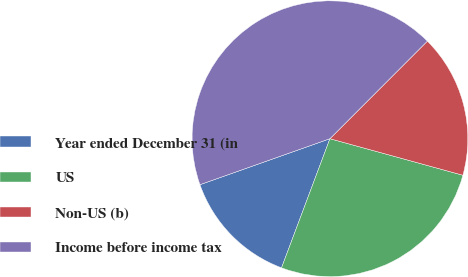Convert chart to OTSL. <chart><loc_0><loc_0><loc_500><loc_500><pie_chart><fcel>Year ended December 31 (in<fcel>US<fcel>Non-US (b)<fcel>Income before income tax<nl><fcel>13.88%<fcel>26.44%<fcel>16.78%<fcel>42.9%<nl></chart> 